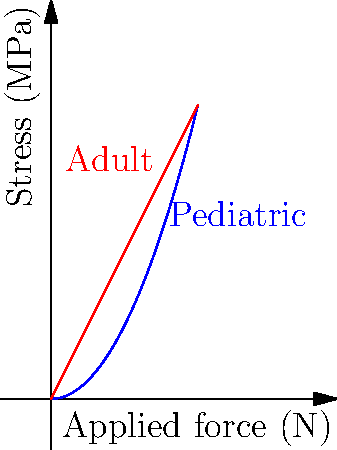Given the stress distribution curves for pediatric and adult bone implants under applied force, what factor contributes most to the observed difference in stress patterns, and how might this impact your surgical approach for pediatric cases? To answer this question, let's analyze the graph and consider the physiological differences between pediatric and adult bones:

1. Observe the curves:
   - The blue curve (pediatric) is nonlinear and increases more rapidly.
   - The red curve (adult) is linear and increases more gradually.

2. Consider bone properties:
   - Pediatric bones are more elastic and less mineralized than adult bones.
   - This leads to different mechanical responses under stress.

3. Analyze the stress distribution:
   - For pediatric implants, stress increases nonlinearly with force ($$\sigma \propto F^2$$).
   - For adult implants, stress increases linearly with force ($$\sigma \propto F$$).

4. Main contributing factor:
   - The elasticity and lower mineral density of pediatric bones cause the nonlinear stress response.

5. Impact on surgical approach:
   - Higher stress concentrations in pediatric cases require careful force distribution.
   - Implant design must account for the nonlinear stress response.
   - Surgical techniques should minimize localized stress to prevent bone damage.

6. Considerations for pediatric cases:
   - Use of more flexible or custom-designed implants.
   - Implementation of gradual force application techniques.
   - Regular post-operative monitoring of bone remodeling and implant integration.
Answer: Bone elasticity and lower mineral density in pediatric patients, requiring adapted implant designs and surgical techniques to manage nonlinear stress distribution. 